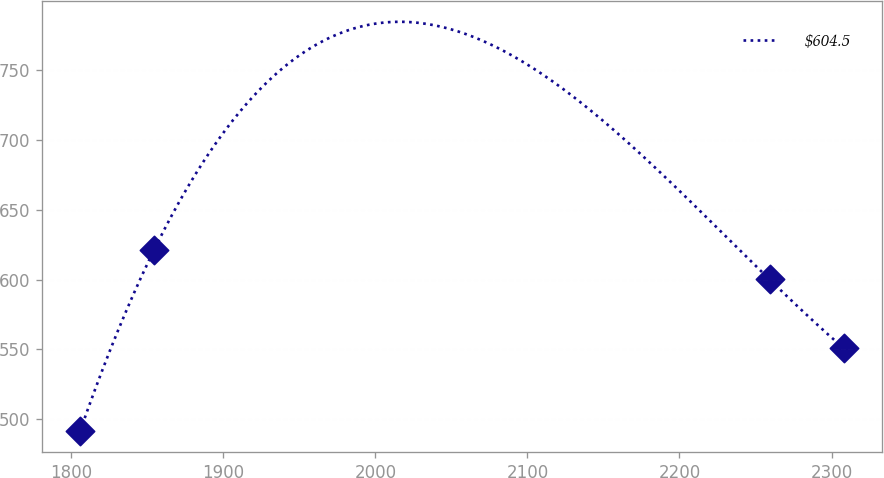Convert chart to OTSL. <chart><loc_0><loc_0><loc_500><loc_500><line_chart><ecel><fcel>$604.5<nl><fcel>1805.79<fcel>491.12<nl><fcel>1854.55<fcel>621.34<nl><fcel>2259.29<fcel>600.01<nl><fcel>2308.05<fcel>550.73<nl></chart> 